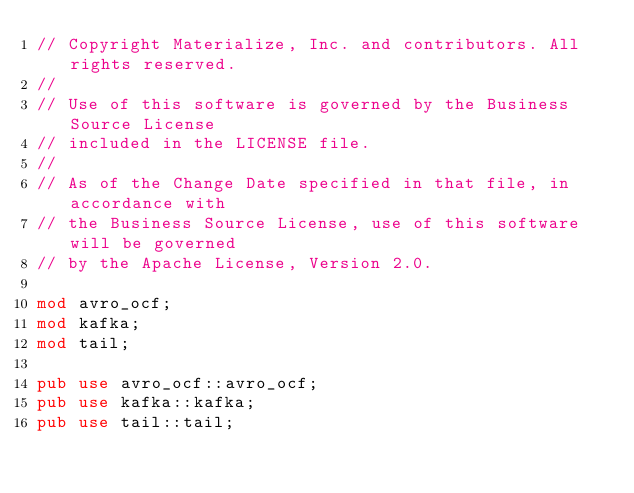<code> <loc_0><loc_0><loc_500><loc_500><_Rust_>// Copyright Materialize, Inc. and contributors. All rights reserved.
//
// Use of this software is governed by the Business Source License
// included in the LICENSE file.
//
// As of the Change Date specified in that file, in accordance with
// the Business Source License, use of this software will be governed
// by the Apache License, Version 2.0.

mod avro_ocf;
mod kafka;
mod tail;

pub use avro_ocf::avro_ocf;
pub use kafka::kafka;
pub use tail::tail;
</code> 